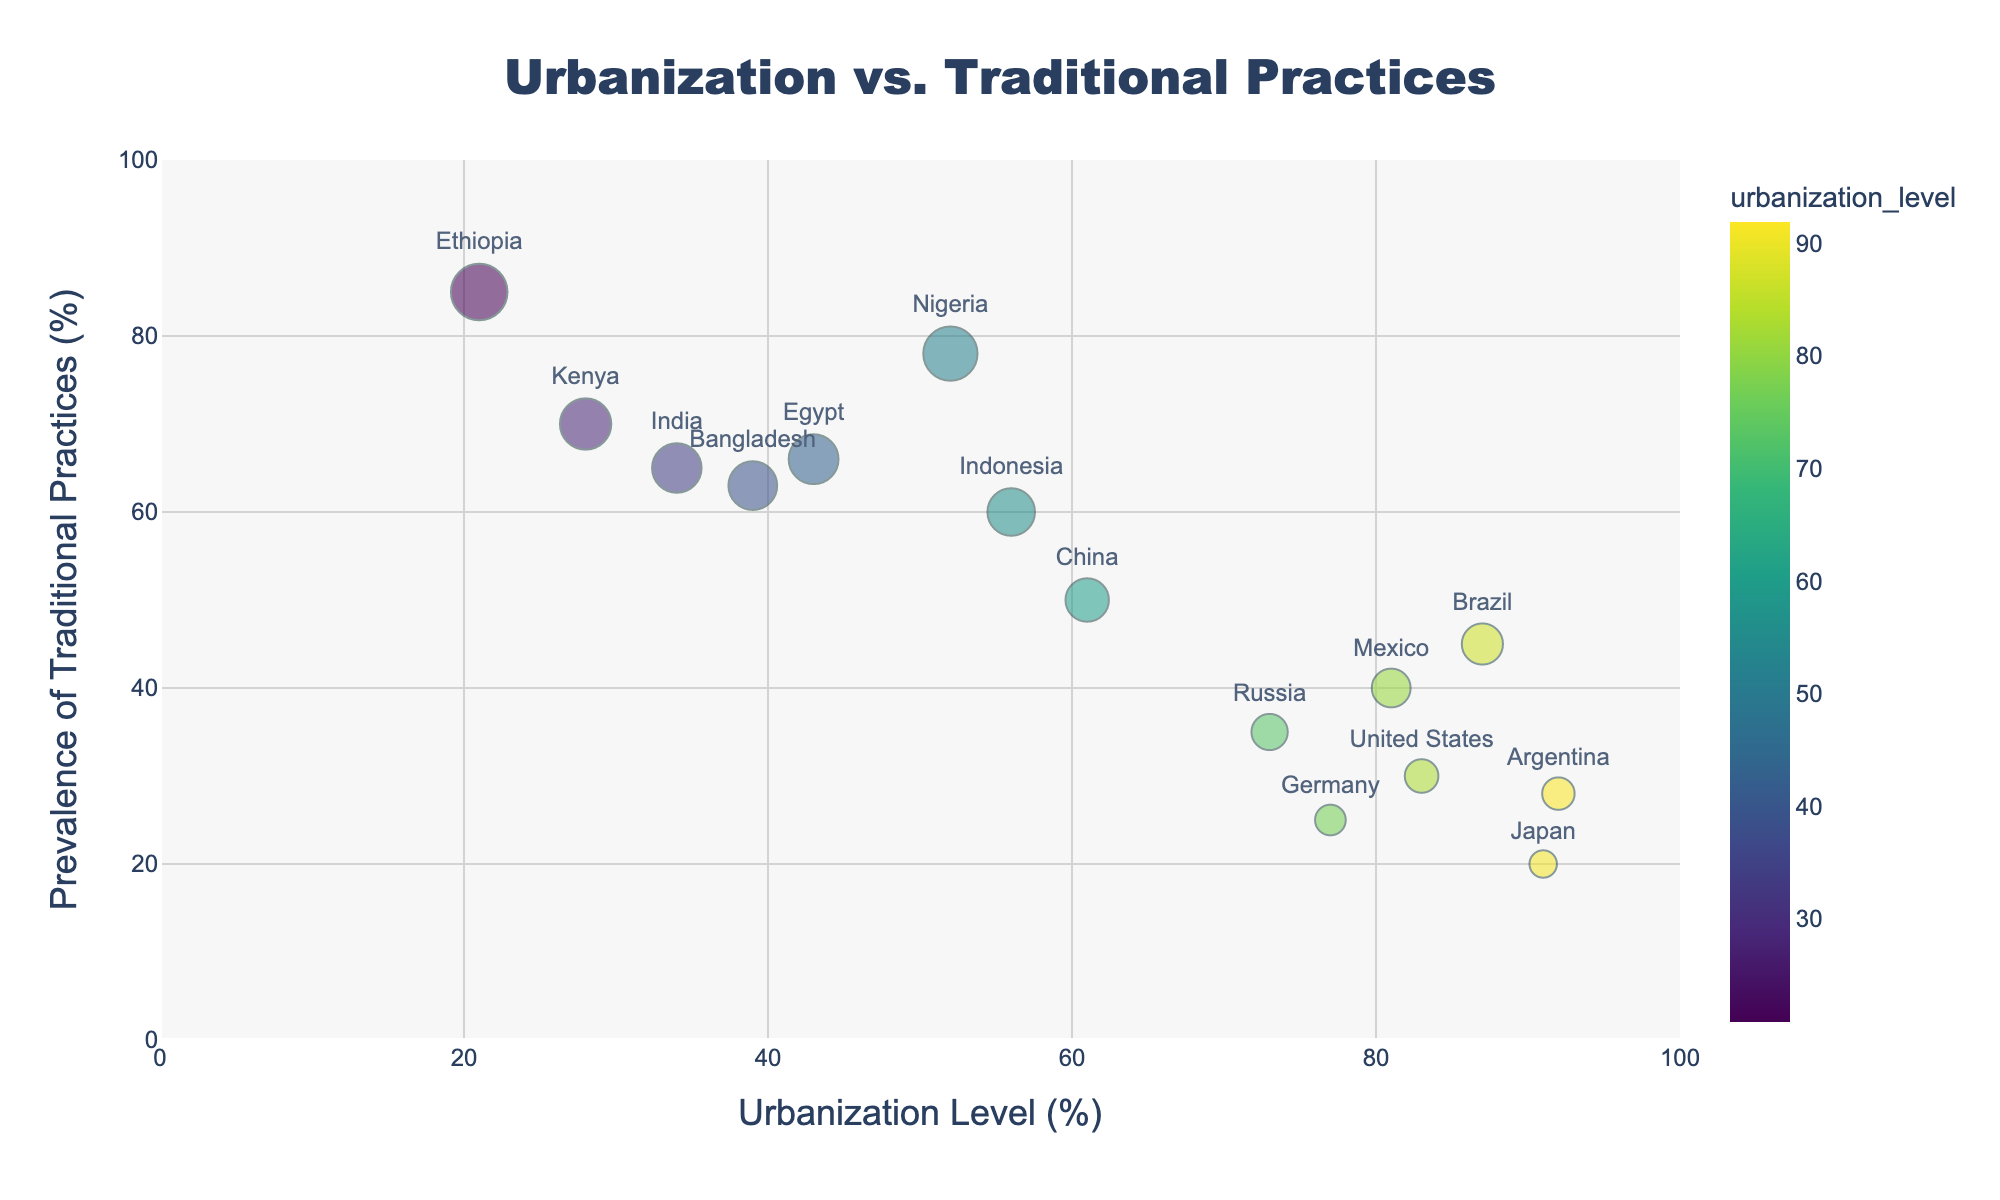Which country has the highest prevalence of traditional practices? By looking at the figure, we can identify the country with the highest position on the y-axis since it represents the prevalence of traditional practices. This country is located at (21, 85) which corresponds to Ethiopia.
Answer: Ethiopia What is the urbanization level of Japan? The text labels mark the positions of the countries on the scatter plot. Identifying Japan in the plot, it is located at the x-value 91.
Answer: 91 Which country has the lowest prevalence of traditional practices? The lowest prevalence of traditional practices is represented by the lowest point on the y-axis. This point correlates with Japan at (91, 20).
Answer: Japan What is the general trend between urbanization level and prevalence of traditional practices? Observing the scatter plot's points distribution, there appears to be a negative trend where countries with higher urbanization levels have lower prevalence of traditional practices and vice versa.
Answer: Negative trend How does the prevalence of traditional practices in the United States compare to China? Checking the y-position on the scatter plot shows that the United States is at 30, and China at 50, indicating the United States has a lower prevalence of traditional practices than China.
Answer: Lower Which country has an urbanization level closest to 50%? Identifying countries near the x-value 50, we see Nigeria at (52, 78).
Answer: Nigeria What's the median prevalence of traditional practices among the listed countries? Sorting prevalence values: 20, 25, 28, 30, 35, 40, 45, 50, 60, 63, 65, 66, 70, 78, 85. The median value, the middle number in this sorted list, is 50.
Answer: 50 Which countries have an urbanization level below 50%? The countries with urbanization levels below 50% are Ethiopia (21), Kenya (28), India (34), and Bangladesh (39).
Answer: Ethiopia, Kenya, India, Bangladesh Out of Brazil and Mexico, which has a higher prevalence of traditional practices? Comparing the y-values of Brazil (45) and Mexico (40) in the scatter plot, Brazil has a higher prevalence of traditional practices than Mexico.
Answer: Brazil What's the range of urbanization levels in the observed countries? The lowest urbanization level is Ethiopia at 21%, and the highest is Japan at 91%. The range is thus 91 - 21 = 70%.
Answer: 70% 